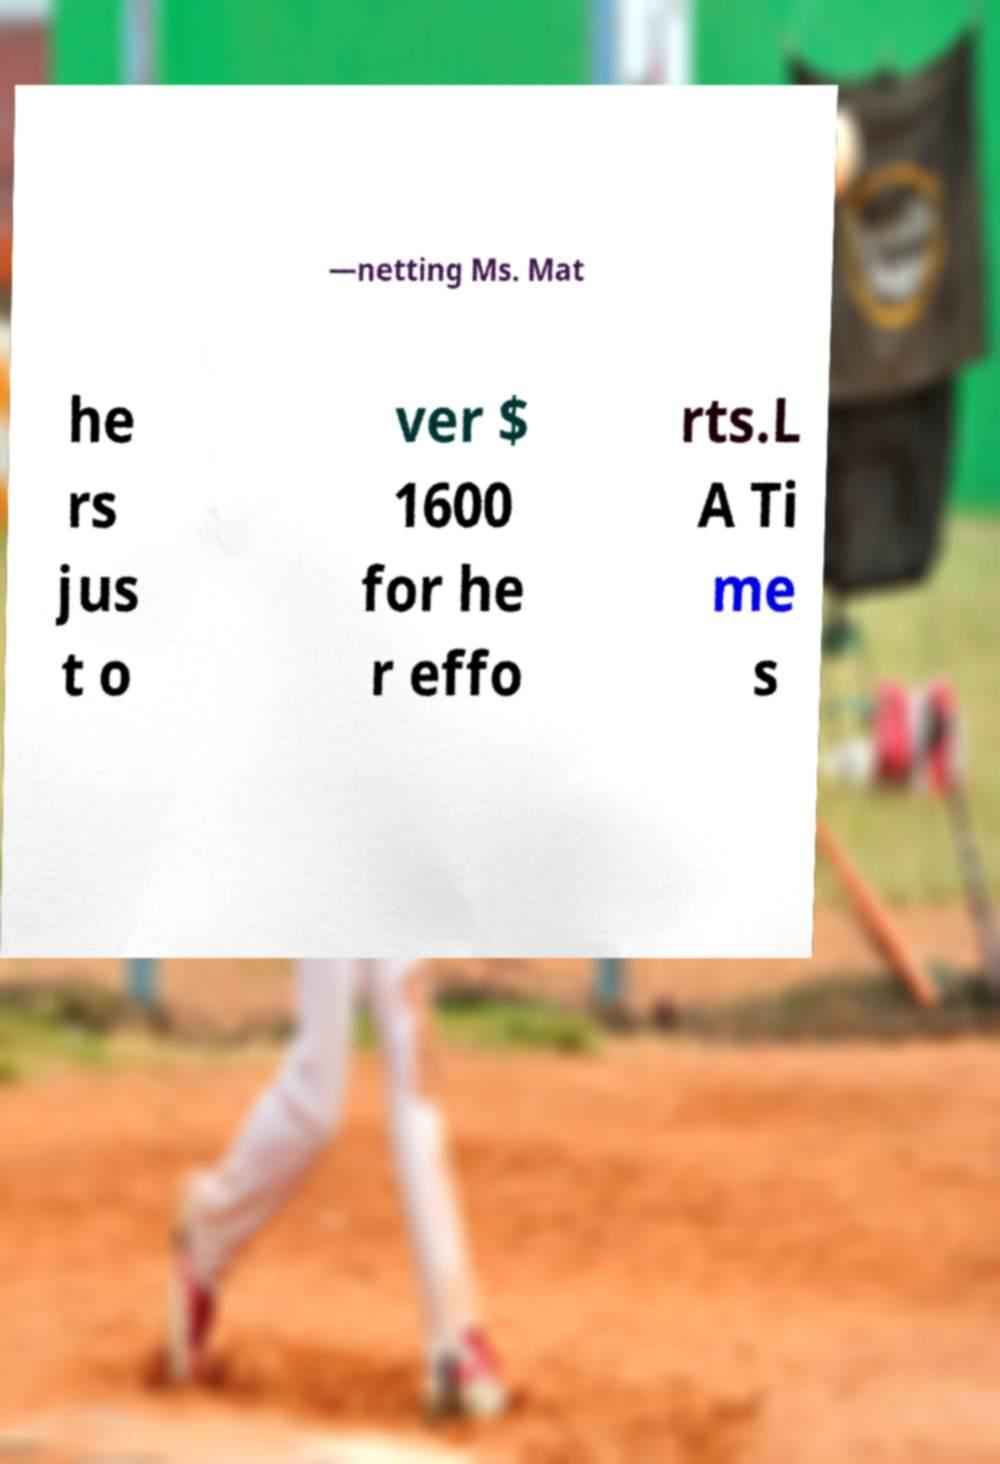Please identify and transcribe the text found in this image. —netting Ms. Mat he rs jus t o ver $ 1600 for he r effo rts.L A Ti me s 